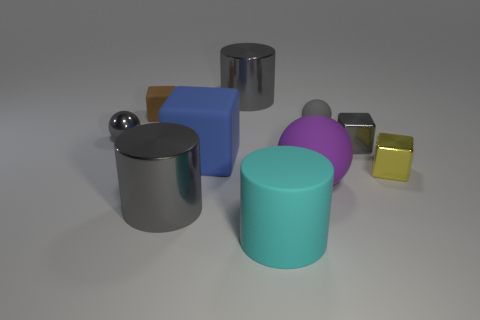What number of big gray things are in front of the gray block and behind the small yellow block?
Your answer should be very brief. 0. There is a tiny thing on the left side of the cube behind the tiny matte object right of the large matte cube; what shape is it?
Your answer should be very brief. Sphere. Is there anything else that is the same shape as the blue rubber object?
Give a very brief answer. Yes. What number of balls are either gray things or big blue rubber things?
Provide a succinct answer. 2. There is a large metal cylinder that is in front of the big purple rubber object; does it have the same color as the large rubber sphere?
Your response must be concise. No. There is a tiny gray sphere on the left side of the large gray thing that is left of the gray thing behind the small matte ball; what is it made of?
Your response must be concise. Metal. Is the size of the cyan thing the same as the purple thing?
Give a very brief answer. Yes. There is a big rubber cylinder; is its color the same as the small block that is left of the cyan cylinder?
Give a very brief answer. No. What is the shape of the gray thing that is the same material as the tiny brown cube?
Ensure brevity in your answer.  Sphere. There is a matte thing to the left of the large blue thing; is its shape the same as the cyan object?
Provide a short and direct response. No. 